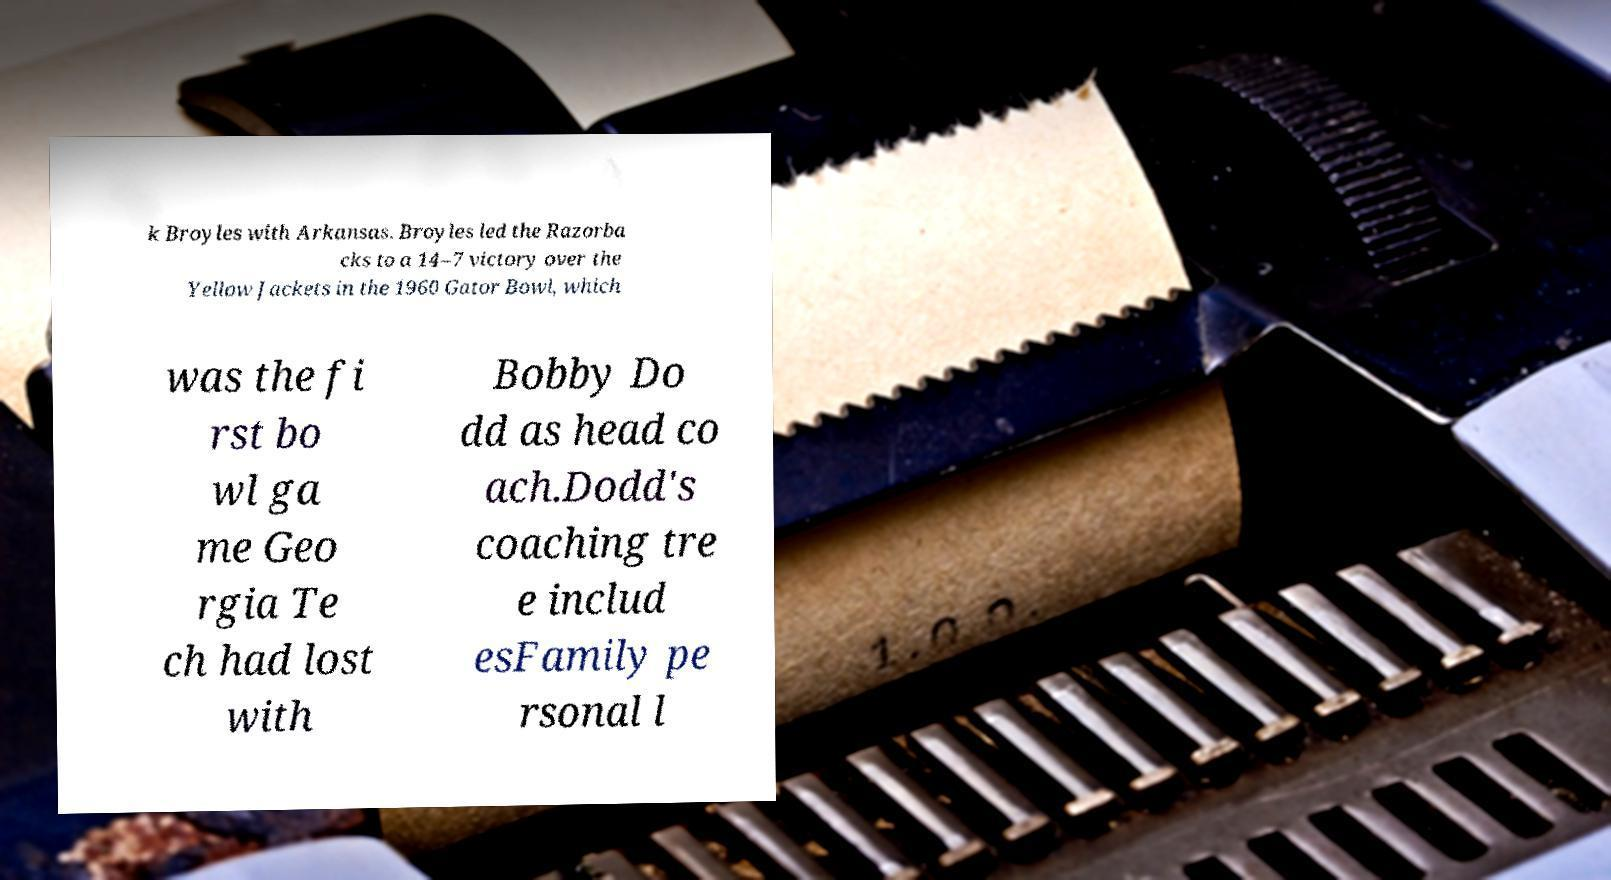Please identify and transcribe the text found in this image. k Broyles with Arkansas. Broyles led the Razorba cks to a 14–7 victory over the Yellow Jackets in the 1960 Gator Bowl, which was the fi rst bo wl ga me Geo rgia Te ch had lost with Bobby Do dd as head co ach.Dodd's coaching tre e includ esFamily pe rsonal l 